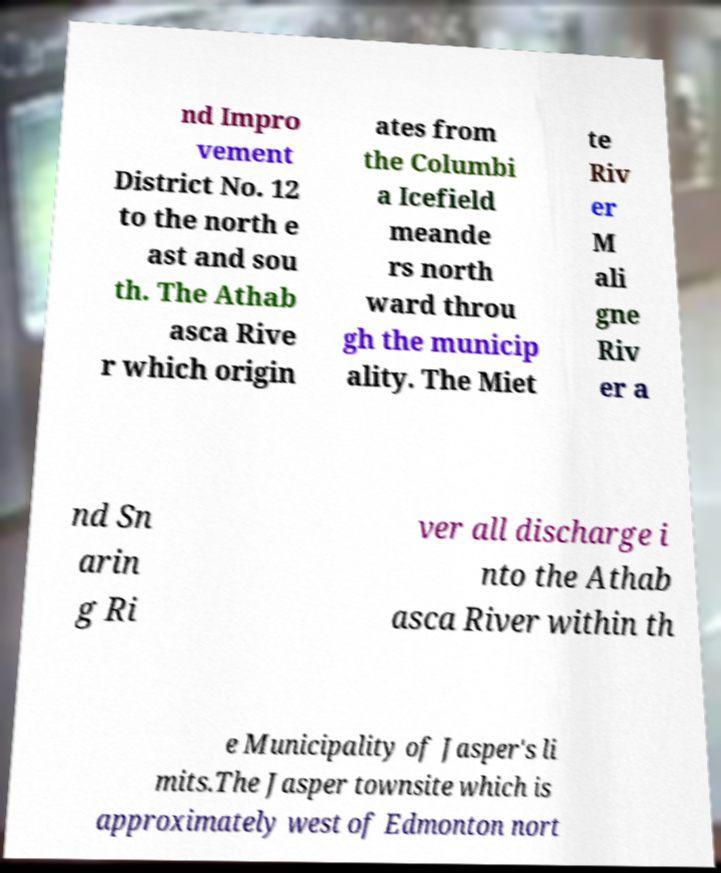Could you assist in decoding the text presented in this image and type it out clearly? nd Impro vement District No. 12 to the north e ast and sou th. The Athab asca Rive r which origin ates from the Columbi a Icefield meande rs north ward throu gh the municip ality. The Miet te Riv er M ali gne Riv er a nd Sn arin g Ri ver all discharge i nto the Athab asca River within th e Municipality of Jasper's li mits.The Jasper townsite which is approximately west of Edmonton nort 